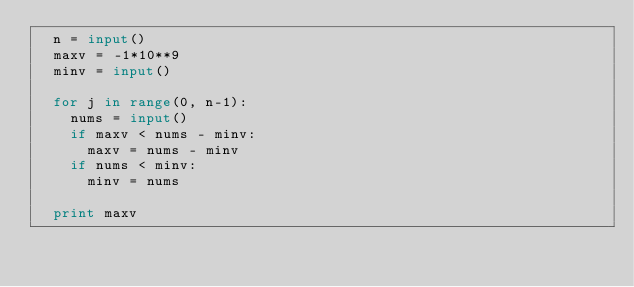Convert code to text. <code><loc_0><loc_0><loc_500><loc_500><_Python_>  n = input()
  maxv = -1*10**9
  minv = input()

  for j in range(0, n-1):
    nums = input()
    if maxv < nums - minv:
      maxv = nums - minv
    if nums < minv:
      minv = nums

  print maxv</code> 